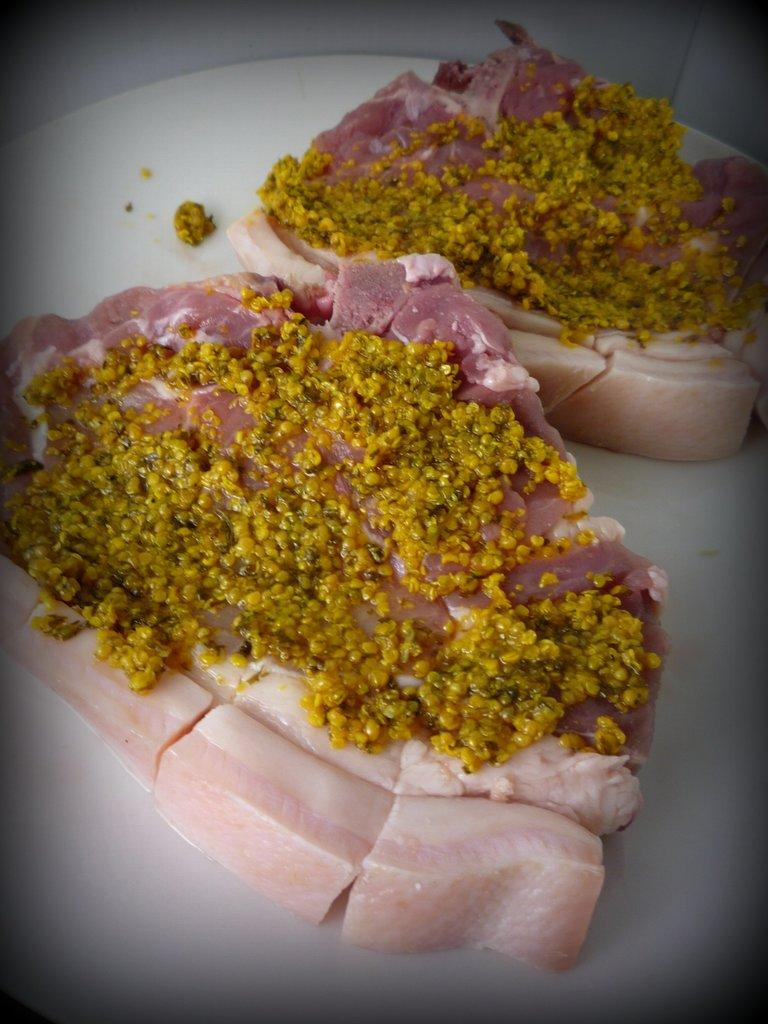What type of objects can be seen in the image? There are food items in the image. How are the food items arranged in the image? The food items are in a plate. Where is the plate located in the image? The plate is on a platform. How many cubs can be seen playing with the food items in the image? There are no cubs present in the image. 